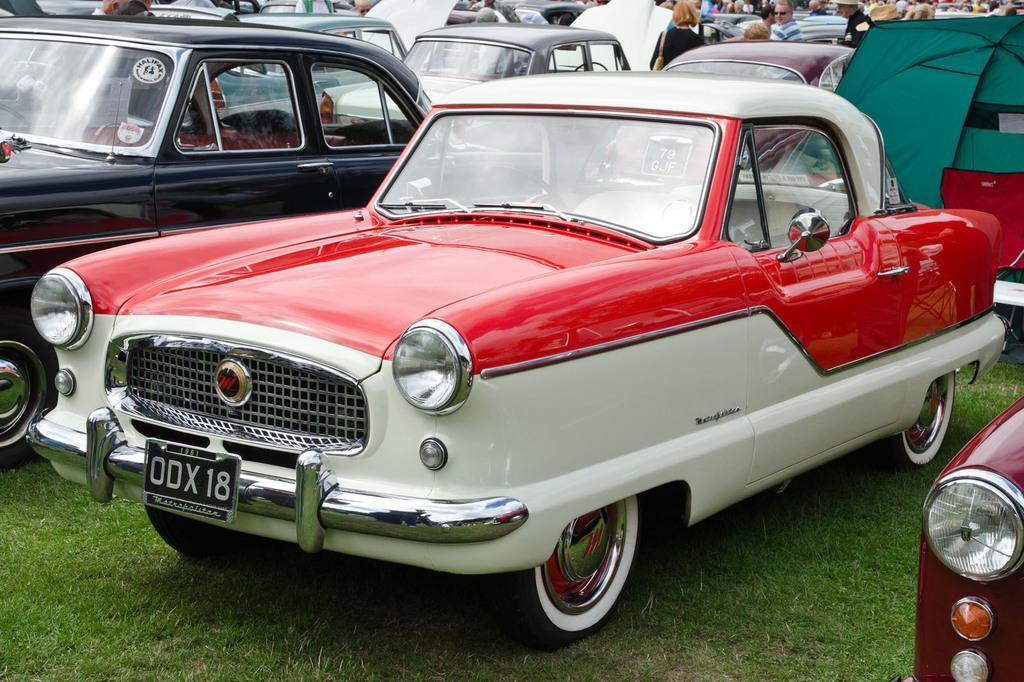How would you summarize this image in a sentence or two? In this image I can see cars with different colours and people and grass on the ground. 